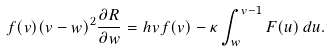<formula> <loc_0><loc_0><loc_500><loc_500>f ( v ) ( v - w ) ^ { 2 } \frac { \partial R } { \partial w } = h v f ( v ) - \kappa \int _ { w } ^ { v - 1 } F ( u ) \, d u .</formula> 